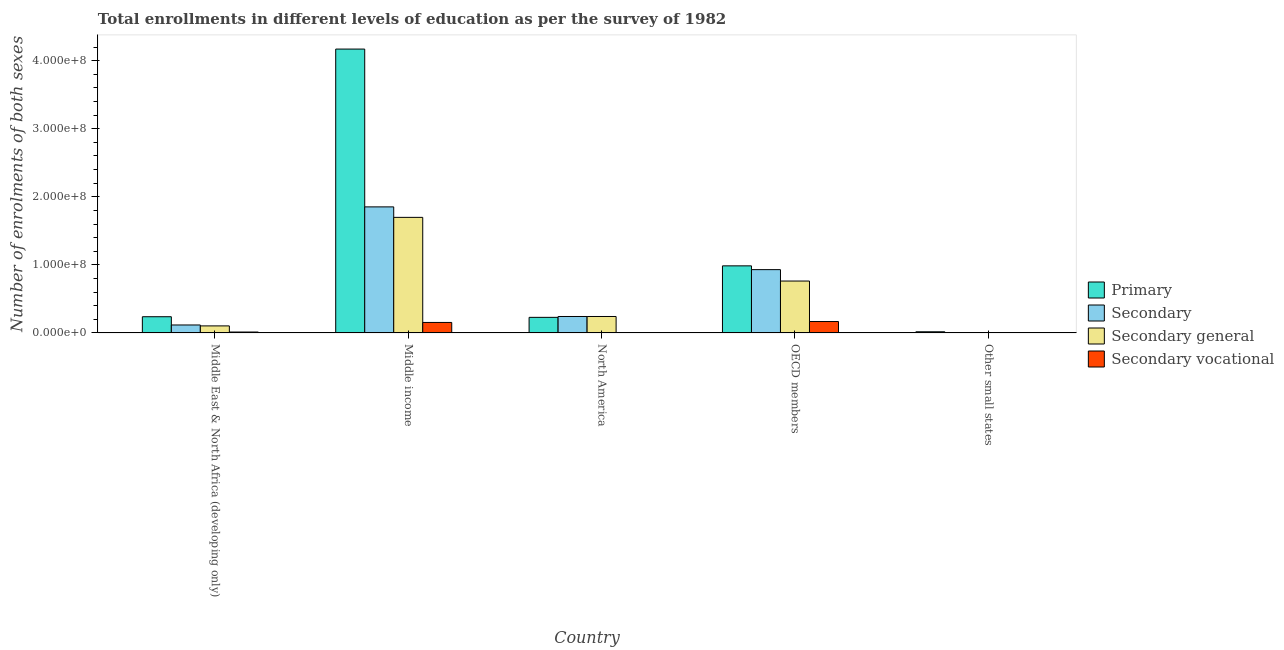Are the number of bars on each tick of the X-axis equal?
Your answer should be very brief. Yes. What is the label of the 2nd group of bars from the left?
Your response must be concise. Middle income. In how many cases, is the number of bars for a given country not equal to the number of legend labels?
Offer a very short reply. 0. What is the number of enrolments in secondary education in Middle East & North Africa (developing only)?
Ensure brevity in your answer.  1.17e+07. Across all countries, what is the maximum number of enrolments in secondary vocational education?
Make the answer very short. 1.68e+07. Across all countries, what is the minimum number of enrolments in secondary education?
Offer a very short reply. 4.06e+05. In which country was the number of enrolments in primary education minimum?
Your response must be concise. Other small states. What is the total number of enrolments in primary education in the graph?
Give a very brief answer. 5.64e+08. What is the difference between the number of enrolments in primary education in Middle East & North Africa (developing only) and that in North America?
Your answer should be very brief. 9.05e+05. What is the difference between the number of enrolments in secondary education in Middle income and the number of enrolments in primary education in North America?
Give a very brief answer. 1.62e+08. What is the average number of enrolments in secondary vocational education per country?
Provide a succinct answer. 6.72e+06. What is the difference between the number of enrolments in secondary general education and number of enrolments in secondary education in Other small states?
Your answer should be compact. -4.80e+04. What is the ratio of the number of enrolments in primary education in Middle East & North Africa (developing only) to that in OECD members?
Keep it short and to the point. 0.24. Is the number of enrolments in primary education in Middle income less than that in OECD members?
Provide a succinct answer. No. What is the difference between the highest and the second highest number of enrolments in secondary general education?
Make the answer very short. 9.35e+07. What is the difference between the highest and the lowest number of enrolments in primary education?
Ensure brevity in your answer.  4.15e+08. What does the 4th bar from the left in North America represents?
Offer a very short reply. Secondary vocational. What does the 3rd bar from the right in North America represents?
Offer a very short reply. Secondary. Is it the case that in every country, the sum of the number of enrolments in primary education and number of enrolments in secondary education is greater than the number of enrolments in secondary general education?
Your response must be concise. Yes. How many bars are there?
Offer a terse response. 20. Are all the bars in the graph horizontal?
Make the answer very short. No. What is the difference between two consecutive major ticks on the Y-axis?
Offer a terse response. 1.00e+08. How are the legend labels stacked?
Keep it short and to the point. Vertical. What is the title of the graph?
Give a very brief answer. Total enrollments in different levels of education as per the survey of 1982. Does "Japan" appear as one of the legend labels in the graph?
Give a very brief answer. No. What is the label or title of the Y-axis?
Your answer should be compact. Number of enrolments of both sexes. What is the Number of enrolments of both sexes in Primary in Middle East & North Africa (developing only)?
Provide a short and direct response. 2.38e+07. What is the Number of enrolments of both sexes in Secondary in Middle East & North Africa (developing only)?
Offer a very short reply. 1.17e+07. What is the Number of enrolments of both sexes of Secondary general in Middle East & North Africa (developing only)?
Ensure brevity in your answer.  1.03e+07. What is the Number of enrolments of both sexes in Secondary vocational in Middle East & North Africa (developing only)?
Your answer should be compact. 1.35e+06. What is the Number of enrolments of both sexes in Primary in Middle income?
Offer a terse response. 4.17e+08. What is the Number of enrolments of both sexes of Secondary in Middle income?
Your response must be concise. 1.85e+08. What is the Number of enrolments of both sexes in Secondary general in Middle income?
Offer a terse response. 1.70e+08. What is the Number of enrolments of both sexes of Secondary vocational in Middle income?
Offer a very short reply. 1.54e+07. What is the Number of enrolments of both sexes in Primary in North America?
Ensure brevity in your answer.  2.29e+07. What is the Number of enrolments of both sexes in Secondary in North America?
Provide a succinct answer. 2.42e+07. What is the Number of enrolments of both sexes of Secondary general in North America?
Your answer should be very brief. 2.42e+07. What is the Number of enrolments of both sexes of Secondary vocational in North America?
Give a very brief answer. 181.77. What is the Number of enrolments of both sexes in Primary in OECD members?
Your answer should be very brief. 9.86e+07. What is the Number of enrolments of both sexes of Secondary in OECD members?
Provide a succinct answer. 9.30e+07. What is the Number of enrolments of both sexes in Secondary general in OECD members?
Provide a succinct answer. 7.62e+07. What is the Number of enrolments of both sexes in Secondary vocational in OECD members?
Offer a very short reply. 1.68e+07. What is the Number of enrolments of both sexes in Primary in Other small states?
Provide a succinct answer. 1.71e+06. What is the Number of enrolments of both sexes of Secondary in Other small states?
Keep it short and to the point. 4.06e+05. What is the Number of enrolments of both sexes in Secondary general in Other small states?
Ensure brevity in your answer.  3.58e+05. What is the Number of enrolments of both sexes of Secondary vocational in Other small states?
Your response must be concise. 4.80e+04. Across all countries, what is the maximum Number of enrolments of both sexes in Primary?
Offer a very short reply. 4.17e+08. Across all countries, what is the maximum Number of enrolments of both sexes of Secondary?
Provide a short and direct response. 1.85e+08. Across all countries, what is the maximum Number of enrolments of both sexes in Secondary general?
Give a very brief answer. 1.70e+08. Across all countries, what is the maximum Number of enrolments of both sexes in Secondary vocational?
Your answer should be very brief. 1.68e+07. Across all countries, what is the minimum Number of enrolments of both sexes of Primary?
Your answer should be very brief. 1.71e+06. Across all countries, what is the minimum Number of enrolments of both sexes of Secondary?
Your answer should be compact. 4.06e+05. Across all countries, what is the minimum Number of enrolments of both sexes of Secondary general?
Offer a very short reply. 3.58e+05. Across all countries, what is the minimum Number of enrolments of both sexes in Secondary vocational?
Ensure brevity in your answer.  181.77. What is the total Number of enrolments of both sexes in Primary in the graph?
Your answer should be very brief. 5.64e+08. What is the total Number of enrolments of both sexes of Secondary in the graph?
Provide a succinct answer. 3.14e+08. What is the total Number of enrolments of both sexes of Secondary general in the graph?
Your answer should be compact. 2.81e+08. What is the total Number of enrolments of both sexes in Secondary vocational in the graph?
Offer a very short reply. 3.36e+07. What is the difference between the Number of enrolments of both sexes of Primary in Middle East & North Africa (developing only) and that in Middle income?
Your answer should be very brief. -3.93e+08. What is the difference between the Number of enrolments of both sexes in Secondary in Middle East & North Africa (developing only) and that in Middle income?
Give a very brief answer. -1.74e+08. What is the difference between the Number of enrolments of both sexes of Secondary general in Middle East & North Africa (developing only) and that in Middle income?
Provide a succinct answer. -1.59e+08. What is the difference between the Number of enrolments of both sexes in Secondary vocational in Middle East & North Africa (developing only) and that in Middle income?
Offer a terse response. -1.41e+07. What is the difference between the Number of enrolments of both sexes in Primary in Middle East & North Africa (developing only) and that in North America?
Ensure brevity in your answer.  9.05e+05. What is the difference between the Number of enrolments of both sexes in Secondary in Middle East & North Africa (developing only) and that in North America?
Offer a terse response. -1.25e+07. What is the difference between the Number of enrolments of both sexes of Secondary general in Middle East & North Africa (developing only) and that in North America?
Provide a short and direct response. -1.38e+07. What is the difference between the Number of enrolments of both sexes of Secondary vocational in Middle East & North Africa (developing only) and that in North America?
Provide a short and direct response. 1.35e+06. What is the difference between the Number of enrolments of both sexes of Primary in Middle East & North Africa (developing only) and that in OECD members?
Give a very brief answer. -7.47e+07. What is the difference between the Number of enrolments of both sexes in Secondary in Middle East & North Africa (developing only) and that in OECD members?
Your answer should be compact. -8.13e+07. What is the difference between the Number of enrolments of both sexes of Secondary general in Middle East & North Africa (developing only) and that in OECD members?
Your answer should be compact. -6.59e+07. What is the difference between the Number of enrolments of both sexes in Secondary vocational in Middle East & North Africa (developing only) and that in OECD members?
Give a very brief answer. -1.54e+07. What is the difference between the Number of enrolments of both sexes in Primary in Middle East & North Africa (developing only) and that in Other small states?
Provide a short and direct response. 2.21e+07. What is the difference between the Number of enrolments of both sexes in Secondary in Middle East & North Africa (developing only) and that in Other small states?
Ensure brevity in your answer.  1.13e+07. What is the difference between the Number of enrolments of both sexes in Secondary general in Middle East & North Africa (developing only) and that in Other small states?
Make the answer very short. 9.99e+06. What is the difference between the Number of enrolments of both sexes in Secondary vocational in Middle East & North Africa (developing only) and that in Other small states?
Give a very brief answer. 1.30e+06. What is the difference between the Number of enrolments of both sexes of Primary in Middle income and that in North America?
Your response must be concise. 3.94e+08. What is the difference between the Number of enrolments of both sexes of Secondary in Middle income and that in North America?
Your answer should be compact. 1.61e+08. What is the difference between the Number of enrolments of both sexes in Secondary general in Middle income and that in North America?
Make the answer very short. 1.46e+08. What is the difference between the Number of enrolments of both sexes in Secondary vocational in Middle income and that in North America?
Ensure brevity in your answer.  1.54e+07. What is the difference between the Number of enrolments of both sexes of Primary in Middle income and that in OECD members?
Provide a succinct answer. 3.18e+08. What is the difference between the Number of enrolments of both sexes in Secondary in Middle income and that in OECD members?
Make the answer very short. 9.22e+07. What is the difference between the Number of enrolments of both sexes of Secondary general in Middle income and that in OECD members?
Offer a terse response. 9.35e+07. What is the difference between the Number of enrolments of both sexes of Secondary vocational in Middle income and that in OECD members?
Offer a very short reply. -1.35e+06. What is the difference between the Number of enrolments of both sexes of Primary in Middle income and that in Other small states?
Ensure brevity in your answer.  4.15e+08. What is the difference between the Number of enrolments of both sexes of Secondary in Middle income and that in Other small states?
Provide a short and direct response. 1.85e+08. What is the difference between the Number of enrolments of both sexes in Secondary general in Middle income and that in Other small states?
Offer a very short reply. 1.69e+08. What is the difference between the Number of enrolments of both sexes in Secondary vocational in Middle income and that in Other small states?
Ensure brevity in your answer.  1.54e+07. What is the difference between the Number of enrolments of both sexes of Primary in North America and that in OECD members?
Offer a terse response. -7.56e+07. What is the difference between the Number of enrolments of both sexes of Secondary in North America and that in OECD members?
Your answer should be very brief. -6.88e+07. What is the difference between the Number of enrolments of both sexes in Secondary general in North America and that in OECD members?
Make the answer very short. -5.21e+07. What is the difference between the Number of enrolments of both sexes of Secondary vocational in North America and that in OECD members?
Offer a very short reply. -1.68e+07. What is the difference between the Number of enrolments of both sexes in Primary in North America and that in Other small states?
Offer a very short reply. 2.12e+07. What is the difference between the Number of enrolments of both sexes in Secondary in North America and that in Other small states?
Make the answer very short. 2.38e+07. What is the difference between the Number of enrolments of both sexes in Secondary general in North America and that in Other small states?
Provide a short and direct response. 2.38e+07. What is the difference between the Number of enrolments of both sexes of Secondary vocational in North America and that in Other small states?
Your answer should be very brief. -4.78e+04. What is the difference between the Number of enrolments of both sexes of Primary in OECD members and that in Other small states?
Your answer should be very brief. 9.69e+07. What is the difference between the Number of enrolments of both sexes in Secondary in OECD members and that in Other small states?
Provide a succinct answer. 9.26e+07. What is the difference between the Number of enrolments of both sexes of Secondary general in OECD members and that in Other small states?
Provide a short and direct response. 7.59e+07. What is the difference between the Number of enrolments of both sexes in Secondary vocational in OECD members and that in Other small states?
Offer a very short reply. 1.67e+07. What is the difference between the Number of enrolments of both sexes of Primary in Middle East & North Africa (developing only) and the Number of enrolments of both sexes of Secondary in Middle income?
Make the answer very short. -1.61e+08. What is the difference between the Number of enrolments of both sexes of Primary in Middle East & North Africa (developing only) and the Number of enrolments of both sexes of Secondary general in Middle income?
Your answer should be very brief. -1.46e+08. What is the difference between the Number of enrolments of both sexes of Primary in Middle East & North Africa (developing only) and the Number of enrolments of both sexes of Secondary vocational in Middle income?
Give a very brief answer. 8.40e+06. What is the difference between the Number of enrolments of both sexes of Secondary in Middle East & North Africa (developing only) and the Number of enrolments of both sexes of Secondary general in Middle income?
Provide a succinct answer. -1.58e+08. What is the difference between the Number of enrolments of both sexes in Secondary in Middle East & North Africa (developing only) and the Number of enrolments of both sexes in Secondary vocational in Middle income?
Your answer should be compact. -3.72e+06. What is the difference between the Number of enrolments of both sexes of Secondary general in Middle East & North Africa (developing only) and the Number of enrolments of both sexes of Secondary vocational in Middle income?
Ensure brevity in your answer.  -5.07e+06. What is the difference between the Number of enrolments of both sexes of Primary in Middle East & North Africa (developing only) and the Number of enrolments of both sexes of Secondary in North America?
Your answer should be very brief. -3.57e+05. What is the difference between the Number of enrolments of both sexes of Primary in Middle East & North Africa (developing only) and the Number of enrolments of both sexes of Secondary general in North America?
Keep it short and to the point. -3.56e+05. What is the difference between the Number of enrolments of both sexes in Primary in Middle East & North Africa (developing only) and the Number of enrolments of both sexes in Secondary vocational in North America?
Provide a succinct answer. 2.38e+07. What is the difference between the Number of enrolments of both sexes in Secondary in Middle East & North Africa (developing only) and the Number of enrolments of both sexes in Secondary general in North America?
Provide a succinct answer. -1.25e+07. What is the difference between the Number of enrolments of both sexes in Secondary in Middle East & North Africa (developing only) and the Number of enrolments of both sexes in Secondary vocational in North America?
Give a very brief answer. 1.17e+07. What is the difference between the Number of enrolments of both sexes in Secondary general in Middle East & North Africa (developing only) and the Number of enrolments of both sexes in Secondary vocational in North America?
Offer a terse response. 1.03e+07. What is the difference between the Number of enrolments of both sexes in Primary in Middle East & North Africa (developing only) and the Number of enrolments of both sexes in Secondary in OECD members?
Provide a succinct answer. -6.92e+07. What is the difference between the Number of enrolments of both sexes of Primary in Middle East & North Africa (developing only) and the Number of enrolments of both sexes of Secondary general in OECD members?
Offer a terse response. -5.24e+07. What is the difference between the Number of enrolments of both sexes in Primary in Middle East & North Africa (developing only) and the Number of enrolments of both sexes in Secondary vocational in OECD members?
Your answer should be compact. 7.05e+06. What is the difference between the Number of enrolments of both sexes of Secondary in Middle East & North Africa (developing only) and the Number of enrolments of both sexes of Secondary general in OECD members?
Make the answer very short. -6.45e+07. What is the difference between the Number of enrolments of both sexes of Secondary in Middle East & North Africa (developing only) and the Number of enrolments of both sexes of Secondary vocational in OECD members?
Offer a terse response. -5.07e+06. What is the difference between the Number of enrolments of both sexes of Secondary general in Middle East & North Africa (developing only) and the Number of enrolments of both sexes of Secondary vocational in OECD members?
Provide a short and direct response. -6.42e+06. What is the difference between the Number of enrolments of both sexes of Primary in Middle East & North Africa (developing only) and the Number of enrolments of both sexes of Secondary in Other small states?
Ensure brevity in your answer.  2.34e+07. What is the difference between the Number of enrolments of both sexes in Primary in Middle East & North Africa (developing only) and the Number of enrolments of both sexes in Secondary general in Other small states?
Provide a succinct answer. 2.35e+07. What is the difference between the Number of enrolments of both sexes in Primary in Middle East & North Africa (developing only) and the Number of enrolments of both sexes in Secondary vocational in Other small states?
Your answer should be compact. 2.38e+07. What is the difference between the Number of enrolments of both sexes in Secondary in Middle East & North Africa (developing only) and the Number of enrolments of both sexes in Secondary general in Other small states?
Your answer should be very brief. 1.13e+07. What is the difference between the Number of enrolments of both sexes in Secondary in Middle East & North Africa (developing only) and the Number of enrolments of both sexes in Secondary vocational in Other small states?
Your answer should be very brief. 1.16e+07. What is the difference between the Number of enrolments of both sexes in Secondary general in Middle East & North Africa (developing only) and the Number of enrolments of both sexes in Secondary vocational in Other small states?
Make the answer very short. 1.03e+07. What is the difference between the Number of enrolments of both sexes of Primary in Middle income and the Number of enrolments of both sexes of Secondary in North America?
Offer a very short reply. 3.93e+08. What is the difference between the Number of enrolments of both sexes of Primary in Middle income and the Number of enrolments of both sexes of Secondary general in North America?
Offer a terse response. 3.93e+08. What is the difference between the Number of enrolments of both sexes in Primary in Middle income and the Number of enrolments of both sexes in Secondary vocational in North America?
Provide a short and direct response. 4.17e+08. What is the difference between the Number of enrolments of both sexes of Secondary in Middle income and the Number of enrolments of both sexes of Secondary general in North America?
Keep it short and to the point. 1.61e+08. What is the difference between the Number of enrolments of both sexes of Secondary in Middle income and the Number of enrolments of both sexes of Secondary vocational in North America?
Your answer should be compact. 1.85e+08. What is the difference between the Number of enrolments of both sexes in Secondary general in Middle income and the Number of enrolments of both sexes in Secondary vocational in North America?
Ensure brevity in your answer.  1.70e+08. What is the difference between the Number of enrolments of both sexes in Primary in Middle income and the Number of enrolments of both sexes in Secondary in OECD members?
Make the answer very short. 3.24e+08. What is the difference between the Number of enrolments of both sexes in Primary in Middle income and the Number of enrolments of both sexes in Secondary general in OECD members?
Your answer should be very brief. 3.41e+08. What is the difference between the Number of enrolments of both sexes of Primary in Middle income and the Number of enrolments of both sexes of Secondary vocational in OECD members?
Offer a terse response. 4.00e+08. What is the difference between the Number of enrolments of both sexes of Secondary in Middle income and the Number of enrolments of both sexes of Secondary general in OECD members?
Provide a short and direct response. 1.09e+08. What is the difference between the Number of enrolments of both sexes of Secondary in Middle income and the Number of enrolments of both sexes of Secondary vocational in OECD members?
Keep it short and to the point. 1.68e+08. What is the difference between the Number of enrolments of both sexes in Secondary general in Middle income and the Number of enrolments of both sexes in Secondary vocational in OECD members?
Ensure brevity in your answer.  1.53e+08. What is the difference between the Number of enrolments of both sexes of Primary in Middle income and the Number of enrolments of both sexes of Secondary in Other small states?
Offer a terse response. 4.17e+08. What is the difference between the Number of enrolments of both sexes in Primary in Middle income and the Number of enrolments of both sexes in Secondary general in Other small states?
Provide a short and direct response. 4.17e+08. What is the difference between the Number of enrolments of both sexes in Primary in Middle income and the Number of enrolments of both sexes in Secondary vocational in Other small states?
Offer a terse response. 4.17e+08. What is the difference between the Number of enrolments of both sexes in Secondary in Middle income and the Number of enrolments of both sexes in Secondary general in Other small states?
Your answer should be compact. 1.85e+08. What is the difference between the Number of enrolments of both sexes of Secondary in Middle income and the Number of enrolments of both sexes of Secondary vocational in Other small states?
Make the answer very short. 1.85e+08. What is the difference between the Number of enrolments of both sexes of Secondary general in Middle income and the Number of enrolments of both sexes of Secondary vocational in Other small states?
Offer a terse response. 1.70e+08. What is the difference between the Number of enrolments of both sexes of Primary in North America and the Number of enrolments of both sexes of Secondary in OECD members?
Provide a short and direct response. -7.01e+07. What is the difference between the Number of enrolments of both sexes of Primary in North America and the Number of enrolments of both sexes of Secondary general in OECD members?
Your answer should be very brief. -5.33e+07. What is the difference between the Number of enrolments of both sexes of Primary in North America and the Number of enrolments of both sexes of Secondary vocational in OECD members?
Provide a succinct answer. 6.15e+06. What is the difference between the Number of enrolments of both sexes in Secondary in North America and the Number of enrolments of both sexes in Secondary general in OECD members?
Provide a succinct answer. -5.21e+07. What is the difference between the Number of enrolments of both sexes in Secondary in North America and the Number of enrolments of both sexes in Secondary vocational in OECD members?
Provide a short and direct response. 7.41e+06. What is the difference between the Number of enrolments of both sexes of Secondary general in North America and the Number of enrolments of both sexes of Secondary vocational in OECD members?
Keep it short and to the point. 7.41e+06. What is the difference between the Number of enrolments of both sexes in Primary in North America and the Number of enrolments of both sexes in Secondary in Other small states?
Your response must be concise. 2.25e+07. What is the difference between the Number of enrolments of both sexes in Primary in North America and the Number of enrolments of both sexes in Secondary general in Other small states?
Provide a short and direct response. 2.26e+07. What is the difference between the Number of enrolments of both sexes of Primary in North America and the Number of enrolments of both sexes of Secondary vocational in Other small states?
Your response must be concise. 2.29e+07. What is the difference between the Number of enrolments of both sexes in Secondary in North America and the Number of enrolments of both sexes in Secondary general in Other small states?
Keep it short and to the point. 2.38e+07. What is the difference between the Number of enrolments of both sexes of Secondary in North America and the Number of enrolments of both sexes of Secondary vocational in Other small states?
Provide a succinct answer. 2.41e+07. What is the difference between the Number of enrolments of both sexes in Secondary general in North America and the Number of enrolments of both sexes in Secondary vocational in Other small states?
Give a very brief answer. 2.41e+07. What is the difference between the Number of enrolments of both sexes in Primary in OECD members and the Number of enrolments of both sexes in Secondary in Other small states?
Offer a terse response. 9.82e+07. What is the difference between the Number of enrolments of both sexes of Primary in OECD members and the Number of enrolments of both sexes of Secondary general in Other small states?
Your answer should be compact. 9.82e+07. What is the difference between the Number of enrolments of both sexes of Primary in OECD members and the Number of enrolments of both sexes of Secondary vocational in Other small states?
Make the answer very short. 9.85e+07. What is the difference between the Number of enrolments of both sexes in Secondary in OECD members and the Number of enrolments of both sexes in Secondary general in Other small states?
Give a very brief answer. 9.27e+07. What is the difference between the Number of enrolments of both sexes in Secondary in OECD members and the Number of enrolments of both sexes in Secondary vocational in Other small states?
Provide a succinct answer. 9.30e+07. What is the difference between the Number of enrolments of both sexes of Secondary general in OECD members and the Number of enrolments of both sexes of Secondary vocational in Other small states?
Give a very brief answer. 7.62e+07. What is the average Number of enrolments of both sexes in Primary per country?
Provide a succinct answer. 1.13e+08. What is the average Number of enrolments of both sexes of Secondary per country?
Ensure brevity in your answer.  6.29e+07. What is the average Number of enrolments of both sexes in Secondary general per country?
Ensure brevity in your answer.  5.62e+07. What is the average Number of enrolments of both sexes of Secondary vocational per country?
Keep it short and to the point. 6.72e+06. What is the difference between the Number of enrolments of both sexes of Primary and Number of enrolments of both sexes of Secondary in Middle East & North Africa (developing only)?
Ensure brevity in your answer.  1.21e+07. What is the difference between the Number of enrolments of both sexes of Primary and Number of enrolments of both sexes of Secondary general in Middle East & North Africa (developing only)?
Provide a short and direct response. 1.35e+07. What is the difference between the Number of enrolments of both sexes of Primary and Number of enrolments of both sexes of Secondary vocational in Middle East & North Africa (developing only)?
Provide a short and direct response. 2.25e+07. What is the difference between the Number of enrolments of both sexes of Secondary and Number of enrolments of both sexes of Secondary general in Middle East & North Africa (developing only)?
Make the answer very short. 1.35e+06. What is the difference between the Number of enrolments of both sexes in Secondary and Number of enrolments of both sexes in Secondary vocational in Middle East & North Africa (developing only)?
Give a very brief answer. 1.03e+07. What is the difference between the Number of enrolments of both sexes in Secondary general and Number of enrolments of both sexes in Secondary vocational in Middle East & North Africa (developing only)?
Provide a succinct answer. 9.00e+06. What is the difference between the Number of enrolments of both sexes in Primary and Number of enrolments of both sexes in Secondary in Middle income?
Offer a very short reply. 2.32e+08. What is the difference between the Number of enrolments of both sexes in Primary and Number of enrolments of both sexes in Secondary general in Middle income?
Make the answer very short. 2.47e+08. What is the difference between the Number of enrolments of both sexes in Primary and Number of enrolments of both sexes in Secondary vocational in Middle income?
Provide a short and direct response. 4.02e+08. What is the difference between the Number of enrolments of both sexes in Secondary and Number of enrolments of both sexes in Secondary general in Middle income?
Your response must be concise. 1.54e+07. What is the difference between the Number of enrolments of both sexes of Secondary and Number of enrolments of both sexes of Secondary vocational in Middle income?
Provide a short and direct response. 1.70e+08. What is the difference between the Number of enrolments of both sexes in Secondary general and Number of enrolments of both sexes in Secondary vocational in Middle income?
Make the answer very short. 1.54e+08. What is the difference between the Number of enrolments of both sexes of Primary and Number of enrolments of both sexes of Secondary in North America?
Ensure brevity in your answer.  -1.26e+06. What is the difference between the Number of enrolments of both sexes in Primary and Number of enrolments of both sexes in Secondary general in North America?
Provide a succinct answer. -1.26e+06. What is the difference between the Number of enrolments of both sexes of Primary and Number of enrolments of both sexes of Secondary vocational in North America?
Offer a very short reply. 2.29e+07. What is the difference between the Number of enrolments of both sexes in Secondary and Number of enrolments of both sexes in Secondary general in North America?
Provide a succinct answer. 180. What is the difference between the Number of enrolments of both sexes of Secondary and Number of enrolments of both sexes of Secondary vocational in North America?
Your response must be concise. 2.42e+07. What is the difference between the Number of enrolments of both sexes in Secondary general and Number of enrolments of both sexes in Secondary vocational in North America?
Your response must be concise. 2.42e+07. What is the difference between the Number of enrolments of both sexes in Primary and Number of enrolments of both sexes in Secondary in OECD members?
Offer a very short reply. 5.55e+06. What is the difference between the Number of enrolments of both sexes of Primary and Number of enrolments of both sexes of Secondary general in OECD members?
Ensure brevity in your answer.  2.23e+07. What is the difference between the Number of enrolments of both sexes in Primary and Number of enrolments of both sexes in Secondary vocational in OECD members?
Keep it short and to the point. 8.18e+07. What is the difference between the Number of enrolments of both sexes in Secondary and Number of enrolments of both sexes in Secondary general in OECD members?
Offer a terse response. 1.68e+07. What is the difference between the Number of enrolments of both sexes in Secondary and Number of enrolments of both sexes in Secondary vocational in OECD members?
Offer a terse response. 7.62e+07. What is the difference between the Number of enrolments of both sexes of Secondary general and Number of enrolments of both sexes of Secondary vocational in OECD members?
Provide a succinct answer. 5.95e+07. What is the difference between the Number of enrolments of both sexes in Primary and Number of enrolments of both sexes in Secondary in Other small states?
Give a very brief answer. 1.30e+06. What is the difference between the Number of enrolments of both sexes of Primary and Number of enrolments of both sexes of Secondary general in Other small states?
Keep it short and to the point. 1.35e+06. What is the difference between the Number of enrolments of both sexes of Primary and Number of enrolments of both sexes of Secondary vocational in Other small states?
Provide a succinct answer. 1.66e+06. What is the difference between the Number of enrolments of both sexes in Secondary and Number of enrolments of both sexes in Secondary general in Other small states?
Offer a terse response. 4.80e+04. What is the difference between the Number of enrolments of both sexes in Secondary and Number of enrolments of both sexes in Secondary vocational in Other small states?
Ensure brevity in your answer.  3.58e+05. What is the difference between the Number of enrolments of both sexes in Secondary general and Number of enrolments of both sexes in Secondary vocational in Other small states?
Your answer should be very brief. 3.10e+05. What is the ratio of the Number of enrolments of both sexes in Primary in Middle East & North Africa (developing only) to that in Middle income?
Provide a short and direct response. 0.06. What is the ratio of the Number of enrolments of both sexes in Secondary in Middle East & North Africa (developing only) to that in Middle income?
Your response must be concise. 0.06. What is the ratio of the Number of enrolments of both sexes in Secondary general in Middle East & North Africa (developing only) to that in Middle income?
Make the answer very short. 0.06. What is the ratio of the Number of enrolments of both sexes of Secondary vocational in Middle East & North Africa (developing only) to that in Middle income?
Offer a terse response. 0.09. What is the ratio of the Number of enrolments of both sexes in Primary in Middle East & North Africa (developing only) to that in North America?
Provide a succinct answer. 1.04. What is the ratio of the Number of enrolments of both sexes of Secondary in Middle East & North Africa (developing only) to that in North America?
Give a very brief answer. 0.48. What is the ratio of the Number of enrolments of both sexes of Secondary general in Middle East & North Africa (developing only) to that in North America?
Provide a succinct answer. 0.43. What is the ratio of the Number of enrolments of both sexes in Secondary vocational in Middle East & North Africa (developing only) to that in North America?
Keep it short and to the point. 7419.37. What is the ratio of the Number of enrolments of both sexes in Primary in Middle East & North Africa (developing only) to that in OECD members?
Provide a short and direct response. 0.24. What is the ratio of the Number of enrolments of both sexes of Secondary in Middle East & North Africa (developing only) to that in OECD members?
Your response must be concise. 0.13. What is the ratio of the Number of enrolments of both sexes of Secondary general in Middle East & North Africa (developing only) to that in OECD members?
Ensure brevity in your answer.  0.14. What is the ratio of the Number of enrolments of both sexes of Secondary vocational in Middle East & North Africa (developing only) to that in OECD members?
Make the answer very short. 0.08. What is the ratio of the Number of enrolments of both sexes in Primary in Middle East & North Africa (developing only) to that in Other small states?
Offer a very short reply. 13.95. What is the ratio of the Number of enrolments of both sexes in Secondary in Middle East & North Africa (developing only) to that in Other small states?
Your response must be concise. 28.81. What is the ratio of the Number of enrolments of both sexes in Secondary general in Middle East & North Africa (developing only) to that in Other small states?
Your response must be concise. 28.9. What is the ratio of the Number of enrolments of both sexes of Secondary vocational in Middle East & North Africa (developing only) to that in Other small states?
Your response must be concise. 28.1. What is the ratio of the Number of enrolments of both sexes in Primary in Middle income to that in North America?
Offer a very short reply. 18.2. What is the ratio of the Number of enrolments of both sexes of Secondary in Middle income to that in North America?
Provide a short and direct response. 7.66. What is the ratio of the Number of enrolments of both sexes in Secondary general in Middle income to that in North America?
Give a very brief answer. 7.02. What is the ratio of the Number of enrolments of both sexes in Secondary vocational in Middle income to that in North America?
Ensure brevity in your answer.  8.48e+04. What is the ratio of the Number of enrolments of both sexes of Primary in Middle income to that in OECD members?
Your answer should be very brief. 4.23. What is the ratio of the Number of enrolments of both sexes in Secondary in Middle income to that in OECD members?
Your response must be concise. 1.99. What is the ratio of the Number of enrolments of both sexes of Secondary general in Middle income to that in OECD members?
Provide a succinct answer. 2.23. What is the ratio of the Number of enrolments of both sexes in Secondary vocational in Middle income to that in OECD members?
Give a very brief answer. 0.92. What is the ratio of the Number of enrolments of both sexes of Primary in Middle income to that in Other small states?
Offer a very short reply. 244.18. What is the ratio of the Number of enrolments of both sexes in Secondary in Middle income to that in Other small states?
Offer a very short reply. 456.11. What is the ratio of the Number of enrolments of both sexes in Secondary general in Middle income to that in Other small states?
Offer a terse response. 474.18. What is the ratio of the Number of enrolments of both sexes of Secondary vocational in Middle income to that in Other small states?
Ensure brevity in your answer.  321.3. What is the ratio of the Number of enrolments of both sexes in Primary in North America to that in OECD members?
Your response must be concise. 0.23. What is the ratio of the Number of enrolments of both sexes in Secondary in North America to that in OECD members?
Offer a terse response. 0.26. What is the ratio of the Number of enrolments of both sexes of Secondary general in North America to that in OECD members?
Your answer should be compact. 0.32. What is the ratio of the Number of enrolments of both sexes of Secondary vocational in North America to that in OECD members?
Provide a short and direct response. 0. What is the ratio of the Number of enrolments of both sexes of Primary in North America to that in Other small states?
Provide a succinct answer. 13.42. What is the ratio of the Number of enrolments of both sexes of Secondary in North America to that in Other small states?
Your answer should be very brief. 59.54. What is the ratio of the Number of enrolments of both sexes of Secondary general in North America to that in Other small states?
Provide a succinct answer. 67.51. What is the ratio of the Number of enrolments of both sexes of Secondary vocational in North America to that in Other small states?
Offer a very short reply. 0. What is the ratio of the Number of enrolments of both sexes of Primary in OECD members to that in Other small states?
Your answer should be very brief. 57.71. What is the ratio of the Number of enrolments of both sexes in Secondary in OECD members to that in Other small states?
Your answer should be very brief. 229.06. What is the ratio of the Number of enrolments of both sexes in Secondary general in OECD members to that in Other small states?
Your answer should be very brief. 212.94. What is the ratio of the Number of enrolments of both sexes in Secondary vocational in OECD members to that in Other small states?
Make the answer very short. 349.35. What is the difference between the highest and the second highest Number of enrolments of both sexes in Primary?
Make the answer very short. 3.18e+08. What is the difference between the highest and the second highest Number of enrolments of both sexes of Secondary?
Keep it short and to the point. 9.22e+07. What is the difference between the highest and the second highest Number of enrolments of both sexes of Secondary general?
Your answer should be compact. 9.35e+07. What is the difference between the highest and the second highest Number of enrolments of both sexes of Secondary vocational?
Make the answer very short. 1.35e+06. What is the difference between the highest and the lowest Number of enrolments of both sexes of Primary?
Ensure brevity in your answer.  4.15e+08. What is the difference between the highest and the lowest Number of enrolments of both sexes of Secondary?
Your response must be concise. 1.85e+08. What is the difference between the highest and the lowest Number of enrolments of both sexes in Secondary general?
Offer a very short reply. 1.69e+08. What is the difference between the highest and the lowest Number of enrolments of both sexes of Secondary vocational?
Your answer should be very brief. 1.68e+07. 